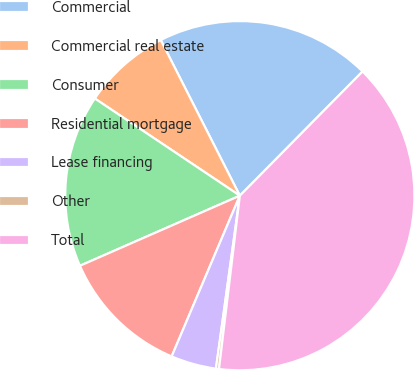Convert chart to OTSL. <chart><loc_0><loc_0><loc_500><loc_500><pie_chart><fcel>Commercial<fcel>Commercial real estate<fcel>Consumer<fcel>Residential mortgage<fcel>Lease financing<fcel>Other<fcel>Total<nl><fcel>19.89%<fcel>8.12%<fcel>15.97%<fcel>12.04%<fcel>4.2%<fcel>0.28%<fcel>39.5%<nl></chart> 